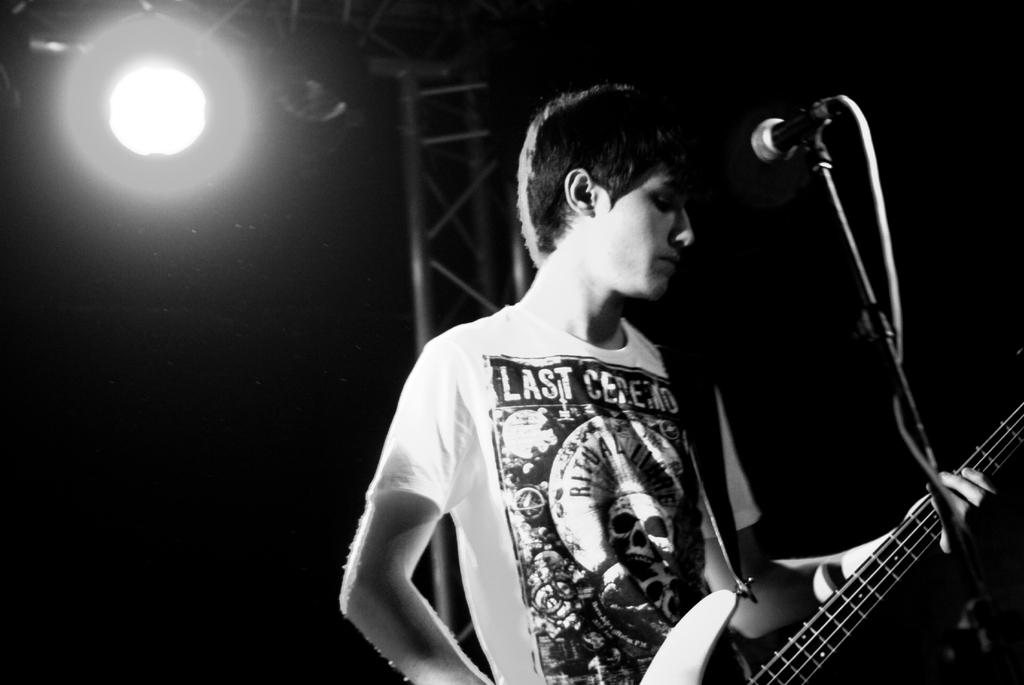What is the color scheme of the image? The image is black and white. Who or what is the main subject in the image? There is a person in the image. What is the person holding? The person is holding a guitar. What is in front of the person? There is a mic in front of the person. Where is the light source in the image? There is a light in the top left corner of the image. What type of acoustics can be heard from the market in the image? There is no market or any sound mentioned in the image, so it's not possible to determine the acoustics. What is the end result of the performance in the image? The image is a still photograph, so there is no performance or end result to be determined. 